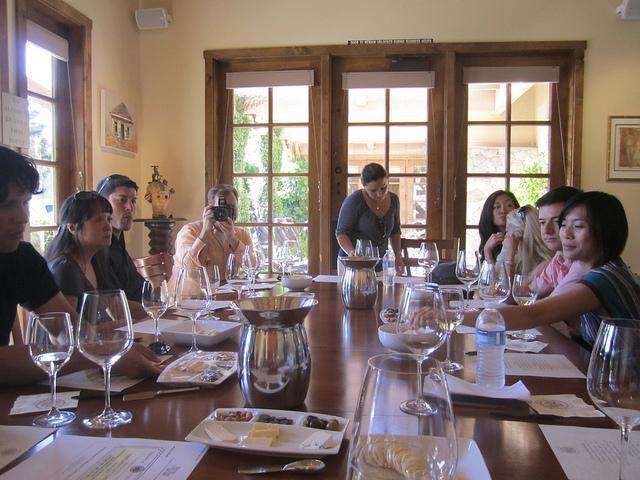How many people are pictured?
Give a very brief answer. 9. How many people are there?
Give a very brief answer. 8. How many wine glasses are in the picture?
Give a very brief answer. 6. 